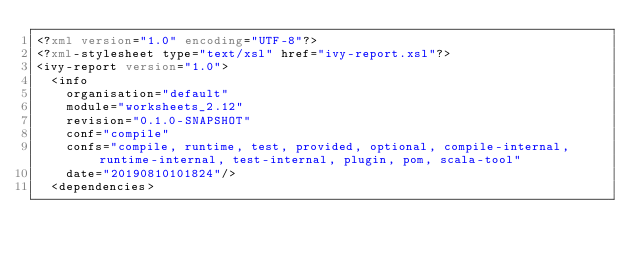<code> <loc_0><loc_0><loc_500><loc_500><_XML_><?xml version="1.0" encoding="UTF-8"?>
<?xml-stylesheet type="text/xsl" href="ivy-report.xsl"?>
<ivy-report version="1.0">
	<info
		organisation="default"
		module="worksheets_2.12"
		revision="0.1.0-SNAPSHOT"
		conf="compile"
		confs="compile, runtime, test, provided, optional, compile-internal, runtime-internal, test-internal, plugin, pom, scala-tool"
		date="20190810101824"/>
	<dependencies></code> 